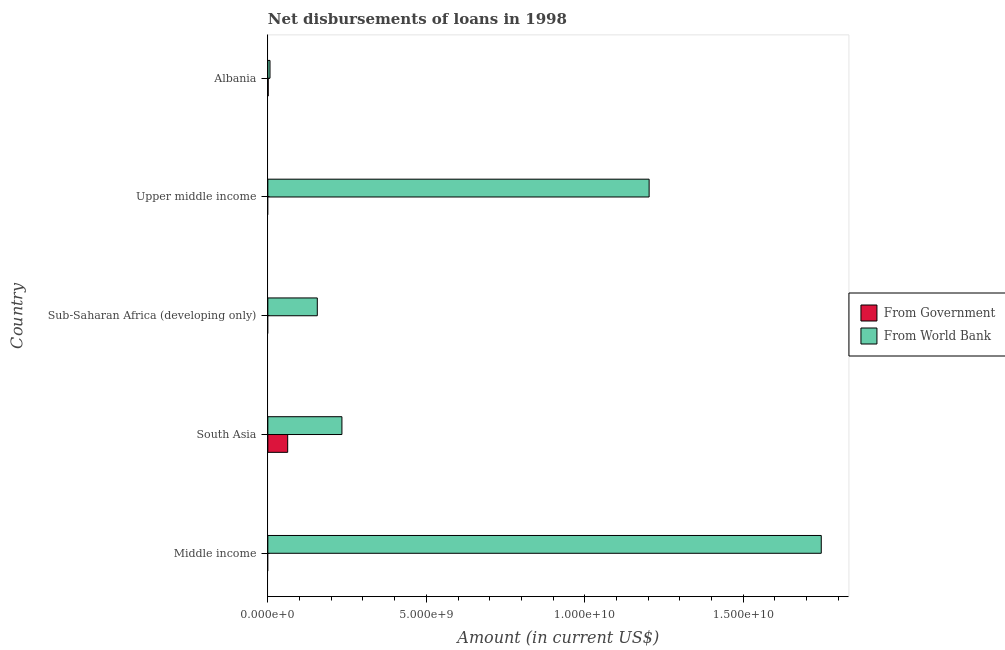How many different coloured bars are there?
Your answer should be compact. 2. What is the label of the 1st group of bars from the top?
Ensure brevity in your answer.  Albania. In how many cases, is the number of bars for a given country not equal to the number of legend labels?
Your answer should be compact. 3. What is the net disbursements of loan from world bank in Middle income?
Offer a very short reply. 1.75e+1. Across all countries, what is the maximum net disbursements of loan from world bank?
Offer a very short reply. 1.75e+1. Across all countries, what is the minimum net disbursements of loan from government?
Provide a succinct answer. 0. What is the total net disbursements of loan from government in the graph?
Ensure brevity in your answer.  6.38e+08. What is the difference between the net disbursements of loan from world bank in Albania and that in South Asia?
Make the answer very short. -2.27e+09. What is the difference between the net disbursements of loan from government in Albania and the net disbursements of loan from world bank in Upper middle income?
Provide a short and direct response. -1.20e+1. What is the average net disbursements of loan from government per country?
Provide a succinct answer. 1.28e+08. What is the difference between the net disbursements of loan from government and net disbursements of loan from world bank in South Asia?
Give a very brief answer. -1.71e+09. What is the ratio of the net disbursements of loan from world bank in Sub-Saharan Africa (developing only) to that in Upper middle income?
Keep it short and to the point. 0.13. What is the difference between the highest and the second highest net disbursements of loan from world bank?
Ensure brevity in your answer.  5.43e+09. What is the difference between the highest and the lowest net disbursements of loan from government?
Offer a terse response. 6.26e+08. In how many countries, is the net disbursements of loan from government greater than the average net disbursements of loan from government taken over all countries?
Your answer should be compact. 1. How many countries are there in the graph?
Provide a short and direct response. 5. What is the difference between two consecutive major ticks on the X-axis?
Provide a succinct answer. 5.00e+09. Where does the legend appear in the graph?
Your answer should be very brief. Center right. How many legend labels are there?
Offer a terse response. 2. How are the legend labels stacked?
Offer a very short reply. Vertical. What is the title of the graph?
Make the answer very short. Net disbursements of loans in 1998. Does "Non-resident workers" appear as one of the legend labels in the graph?
Give a very brief answer. No. What is the label or title of the X-axis?
Your answer should be compact. Amount (in current US$). What is the label or title of the Y-axis?
Give a very brief answer. Country. What is the Amount (in current US$) of From World Bank in Middle income?
Ensure brevity in your answer.  1.75e+1. What is the Amount (in current US$) in From Government in South Asia?
Keep it short and to the point. 6.26e+08. What is the Amount (in current US$) in From World Bank in South Asia?
Provide a succinct answer. 2.34e+09. What is the Amount (in current US$) of From Government in Sub-Saharan Africa (developing only)?
Provide a short and direct response. 0. What is the Amount (in current US$) of From World Bank in Sub-Saharan Africa (developing only)?
Ensure brevity in your answer.  1.56e+09. What is the Amount (in current US$) in From World Bank in Upper middle income?
Your answer should be very brief. 1.20e+1. What is the Amount (in current US$) of From Government in Albania?
Your response must be concise. 1.14e+07. What is the Amount (in current US$) in From World Bank in Albania?
Give a very brief answer. 6.82e+07. Across all countries, what is the maximum Amount (in current US$) of From Government?
Your answer should be very brief. 6.26e+08. Across all countries, what is the maximum Amount (in current US$) of From World Bank?
Provide a succinct answer. 1.75e+1. Across all countries, what is the minimum Amount (in current US$) in From Government?
Offer a very short reply. 0. Across all countries, what is the minimum Amount (in current US$) in From World Bank?
Your answer should be compact. 6.82e+07. What is the total Amount (in current US$) in From Government in the graph?
Offer a very short reply. 6.38e+08. What is the total Amount (in current US$) in From World Bank in the graph?
Offer a terse response. 3.35e+1. What is the difference between the Amount (in current US$) in From World Bank in Middle income and that in South Asia?
Keep it short and to the point. 1.51e+1. What is the difference between the Amount (in current US$) in From World Bank in Middle income and that in Sub-Saharan Africa (developing only)?
Your answer should be compact. 1.59e+1. What is the difference between the Amount (in current US$) of From World Bank in Middle income and that in Upper middle income?
Make the answer very short. 5.43e+09. What is the difference between the Amount (in current US$) of From World Bank in Middle income and that in Albania?
Offer a very short reply. 1.74e+1. What is the difference between the Amount (in current US$) in From World Bank in South Asia and that in Sub-Saharan Africa (developing only)?
Your response must be concise. 7.77e+08. What is the difference between the Amount (in current US$) of From World Bank in South Asia and that in Upper middle income?
Offer a terse response. -9.69e+09. What is the difference between the Amount (in current US$) in From Government in South Asia and that in Albania?
Your answer should be very brief. 6.15e+08. What is the difference between the Amount (in current US$) in From World Bank in South Asia and that in Albania?
Your response must be concise. 2.27e+09. What is the difference between the Amount (in current US$) of From World Bank in Sub-Saharan Africa (developing only) and that in Upper middle income?
Keep it short and to the point. -1.05e+1. What is the difference between the Amount (in current US$) of From World Bank in Sub-Saharan Africa (developing only) and that in Albania?
Ensure brevity in your answer.  1.49e+09. What is the difference between the Amount (in current US$) of From World Bank in Upper middle income and that in Albania?
Your response must be concise. 1.20e+1. What is the difference between the Amount (in current US$) of From Government in South Asia and the Amount (in current US$) of From World Bank in Sub-Saharan Africa (developing only)?
Make the answer very short. -9.34e+08. What is the difference between the Amount (in current US$) of From Government in South Asia and the Amount (in current US$) of From World Bank in Upper middle income?
Your response must be concise. -1.14e+1. What is the difference between the Amount (in current US$) of From Government in South Asia and the Amount (in current US$) of From World Bank in Albania?
Offer a very short reply. 5.58e+08. What is the average Amount (in current US$) of From Government per country?
Provide a succinct answer. 1.28e+08. What is the average Amount (in current US$) in From World Bank per country?
Your response must be concise. 6.69e+09. What is the difference between the Amount (in current US$) in From Government and Amount (in current US$) in From World Bank in South Asia?
Provide a succinct answer. -1.71e+09. What is the difference between the Amount (in current US$) of From Government and Amount (in current US$) of From World Bank in Albania?
Make the answer very short. -5.69e+07. What is the ratio of the Amount (in current US$) of From World Bank in Middle income to that in South Asia?
Your response must be concise. 7.47. What is the ratio of the Amount (in current US$) in From World Bank in Middle income to that in Sub-Saharan Africa (developing only)?
Your answer should be very brief. 11.19. What is the ratio of the Amount (in current US$) of From World Bank in Middle income to that in Upper middle income?
Offer a very short reply. 1.45. What is the ratio of the Amount (in current US$) of From World Bank in Middle income to that in Albania?
Your answer should be very brief. 255.91. What is the ratio of the Amount (in current US$) in From World Bank in South Asia to that in Sub-Saharan Africa (developing only)?
Offer a terse response. 1.5. What is the ratio of the Amount (in current US$) of From World Bank in South Asia to that in Upper middle income?
Keep it short and to the point. 0.19. What is the ratio of the Amount (in current US$) of From Government in South Asia to that in Albania?
Offer a terse response. 55.05. What is the ratio of the Amount (in current US$) of From World Bank in South Asia to that in Albania?
Make the answer very short. 34.25. What is the ratio of the Amount (in current US$) in From World Bank in Sub-Saharan Africa (developing only) to that in Upper middle income?
Ensure brevity in your answer.  0.13. What is the ratio of the Amount (in current US$) of From World Bank in Sub-Saharan Africa (developing only) to that in Albania?
Offer a very short reply. 22.87. What is the ratio of the Amount (in current US$) of From World Bank in Upper middle income to that in Albania?
Provide a succinct answer. 176.31. What is the difference between the highest and the second highest Amount (in current US$) in From World Bank?
Provide a succinct answer. 5.43e+09. What is the difference between the highest and the lowest Amount (in current US$) in From Government?
Provide a succinct answer. 6.26e+08. What is the difference between the highest and the lowest Amount (in current US$) in From World Bank?
Your response must be concise. 1.74e+1. 